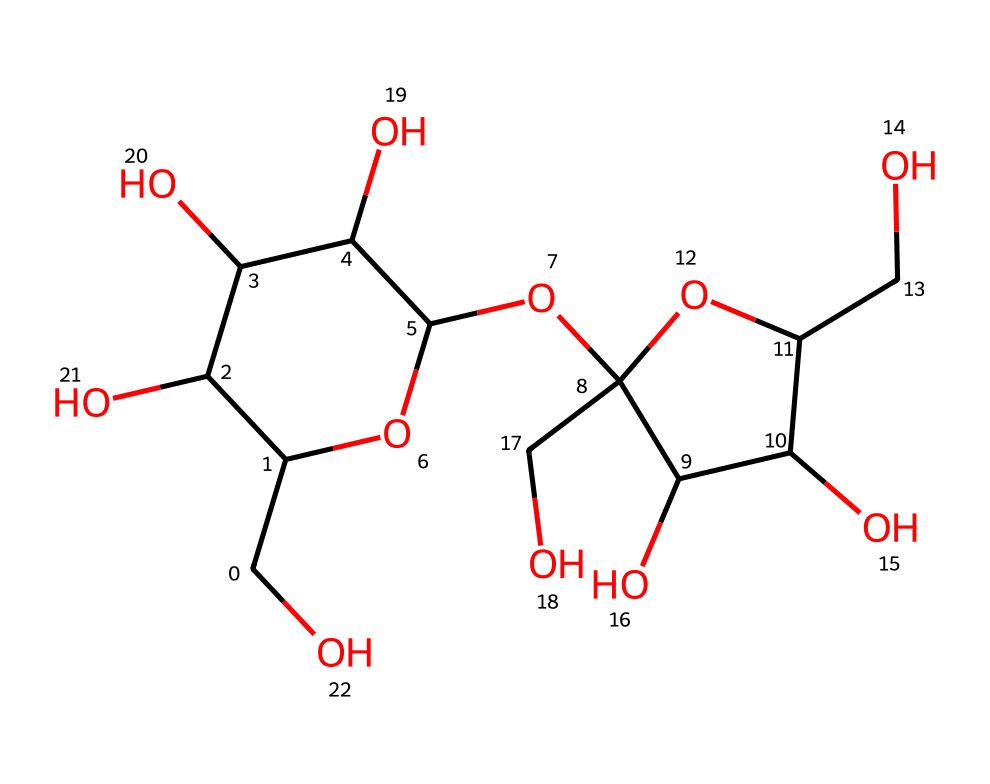How many carbon atoms are present in the structure of sucrose? To determine the number of carbon atoms, analyze the SMILES representation and count each 'C' character that appears. In the provided SMILES, there are 12 instances of 'C', indicating 12 carbon atoms.
Answer: 12 What type of glycosidic bond is present in sucrose? Sucrose consists of a glucose and a fructose unit linked together through a specific glycosidic bond. Analyzing the structure, it's a 1,2-glycosidic bond because it connects the first carbon of glucose to the second carbon of fructose.
Answer: 1,2-glycosidic Which functional groups are found in sucrose? Reviewing the SMILES, we can identify hydroxyl groups, as indicated by the presence of 'O' atoms attached to carbon chains. Each 'O' that has a hydrogen attached (or is a part of an alcohol group) indicates a hydroxyl functional group. In sucrose, multiple hydroxyl groups are present.
Answer: hydroxyl groups What is the molecular formula for sucrose? To derive the molecular formula from the SMILES representation, count the total number of carbon (C), hydrogen (H), and oxygen (O) atoms. From the analysis, there are 12 carbon, 22 hydrogen, and 11 oxygen atoms, leading to the formula C12H22O11.
Answer: C12H22O11 Why does sucrose have a sweet taste? The sweetness of sucrose is attributed to its specific molecular structure, which interacts with taste receptors on the tongue. Analyzing the carbohydrate nature and the glycosidic bonds helps explain that these configurations allow for sensory binding, leading to a sweet perception.
Answer: sweet taste How many hydroxyl groups are present in sucrose? To find the number of hydroxyl groups, observe the presence of -OH sections in the structure. Counting the -OH groups based on the occurrence of the relevant oxygen atoms and their connections to carbon reveals that there are 11 hydroxyl groups in sucrose.
Answer: 11 What is the structural class of sucrose? The analysis of the structure indicates that sucrose can be categorized as a disaccharide, consisting of two monosaccharides (glucose and fructose) linked through a glycosidic bond. Therefore, it belongs to the class of disaccharides within carbohydrates.
Answer: disaccharide 